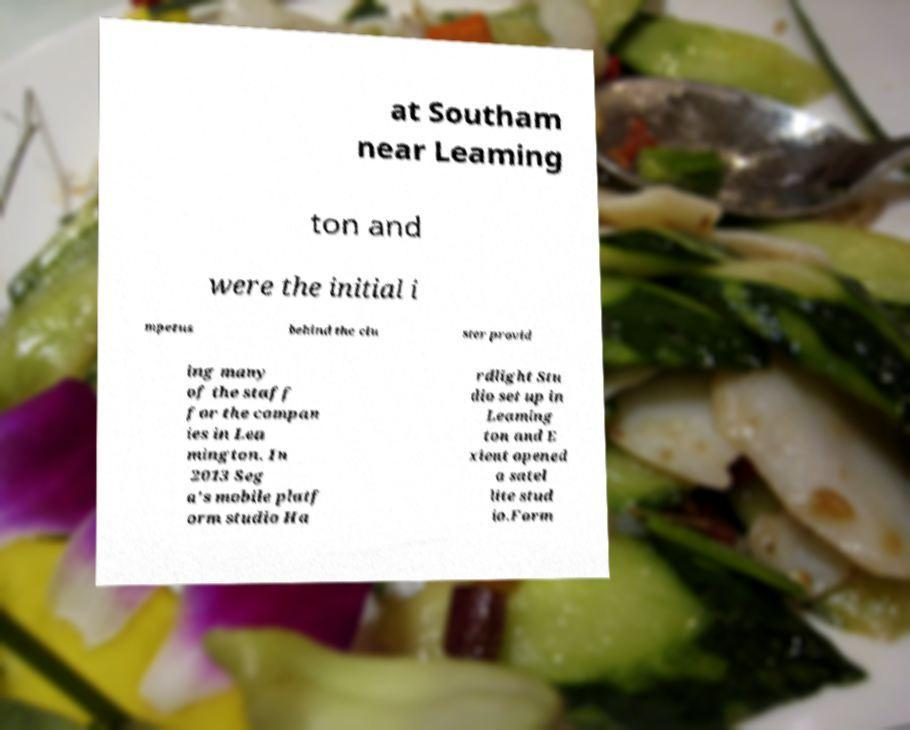I need the written content from this picture converted into text. Can you do that? at Southam near Leaming ton and were the initial i mpetus behind the clu ster provid ing many of the staff for the compan ies in Lea mington. In 2013 Seg a's mobile platf orm studio Ha rdlight Stu dio set up in Leaming ton and E xient opened a satel lite stud io.Form 